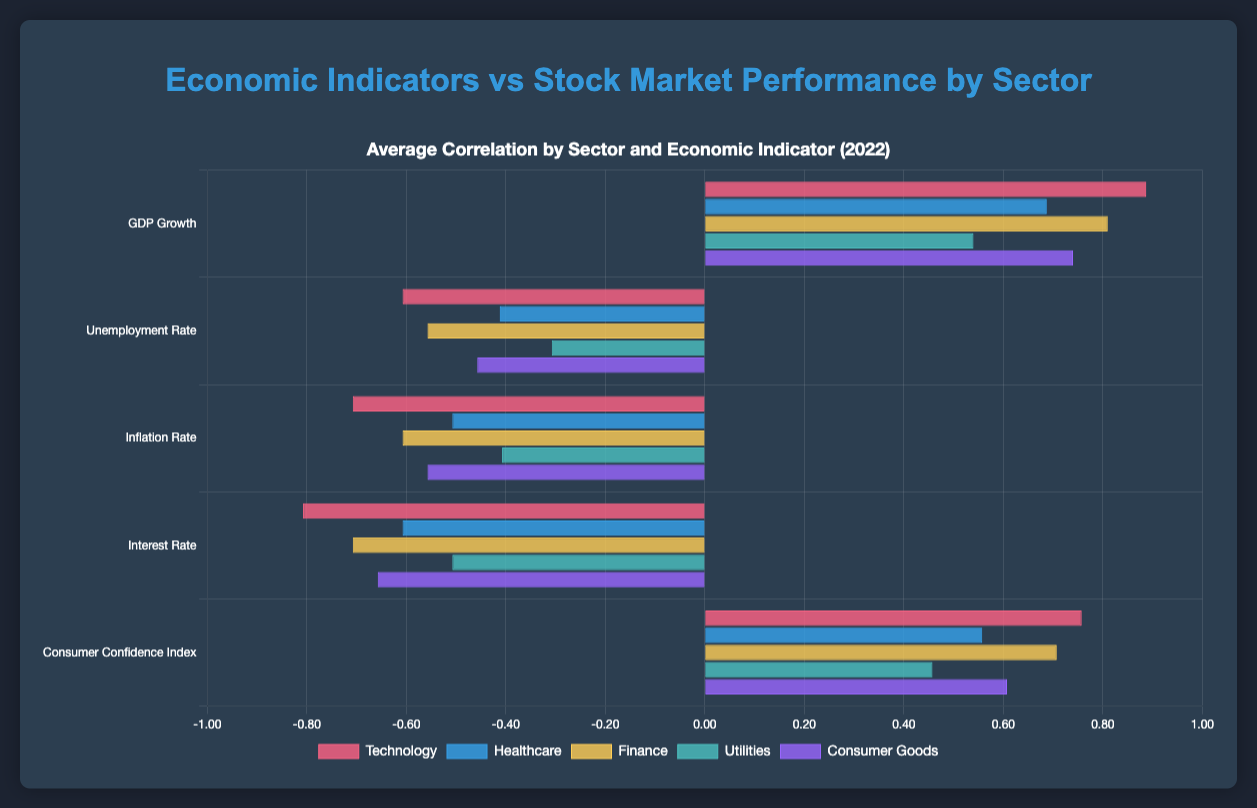What's the average correlation of GDP Growth for Technology sector in 2022? The average correlation for the Technology sector is obtained by averaging the four quarterly values for GDP Growth: (0.85 + 0.90 + 0.88 + 0.92) / 4 = 0.8875
Answer: 0.89 Which sector shows the highest correlation with the Inflation Rate in Q3_2022? In Q3_2022, the correlations with the Inflation Rate are: Technology (-0.71), Healthcare (-0.51), Finance (-0.61), Utilities (-0.41), and Consumer Goods (-0.56). The least negative value is for Healthcare at -0.51.
Answer: Healthcare Is the correlation with GDP Growth in Q4_2022 higher for Technology or Finance? Comparing the correlations in Q4_2022, Technology has 0.92 and Finance has 0.84. 0.92 (Technology) is greater than 0.84 (Finance).
Answer: Technology Calculate the difference between the highest and lowest average correlation for any sector across all indicators. The highest average correlation is for Technology with GDP Growth (0.89) and the lowest is for Utilities with Interest Rate (-0.50). The difference is 0.89 - (-0.50) = 1.39
Answer: 1.39 Which economic indicator shows the highest average correlation across all sectors in 2022? We need to find the average correlations of each indicator across all sectors. After calculation:
- GDP Growth average: (0.89 + 0.69 + 0.81 + 0.54 + 0.74) / 5 = 0.734
- Unemployment Rate average: (-0.61 + -0.41 + -0.56 + -0.31 + -0.46) / 5 = -0.47
- Inflation Rate average: (-0.71 + -0.51 + -0.61 + -0.41 + -0.56) / 5 = -0.56
- Interest Rate average: (-0.81 + -0.61 + -0.71 + -0.51 + -0.66) / 5 = -0.66
- Consumer Confidence Index average: (0.76 + 0.56 + 0.71 + 0.46 + 0.61) / 5 = 0.62
The highest average is GDP Growth at 0.734.
Answer: GDP Growth Between Healthcare and Consumer Goods, which sector has a stronger correlation with the Consumer Confidence Index in Q2_2022? Comparing the correlations in Q2_2022: Healthcare has 0.57 and Consumer Goods has 0.62. 0.62 (Consumer Goods) is higher than 0.57 (Healthcare).
Answer: Consumer Goods What is the range of correlation values for Utilities across all quarters for the Interest Rate? The range is found by: max value: -0.50, min value: -0.52. Range = max - min = -0.50 - (-0.52) = 0.02
Answer: 0.02 Which sector shows the greatest positive change in correlation with GDP Growth from Q1_2022 to Q4_2022? The change for each sector from Q1_2022 to Q4_2022 is: 
- Technology: 0.92 - 0.85 = 0.07 
- Healthcare: 0.72 - 0.65 = 0.07 
- Finance: 0.84 - 0.78 = 0.06 
- Utilities: 0.58 - 0.50 = 0.08 
- Consumer Goods: 0.78 - 0.70 = 0.08
Utilities and Consumer Goods have the greatest positive change of 0.08.
Answer: Utilities and Consumer Goods Identify the sector and economic indicator having the lowest average correlation in 2022. First, calculate the average correlation for each sector and indicator combination. The lowest is for Sector: Utilities and Indicator: Interest Rate, at an average correlation of -0.50.
Answer: Utilities, Interest Rate 